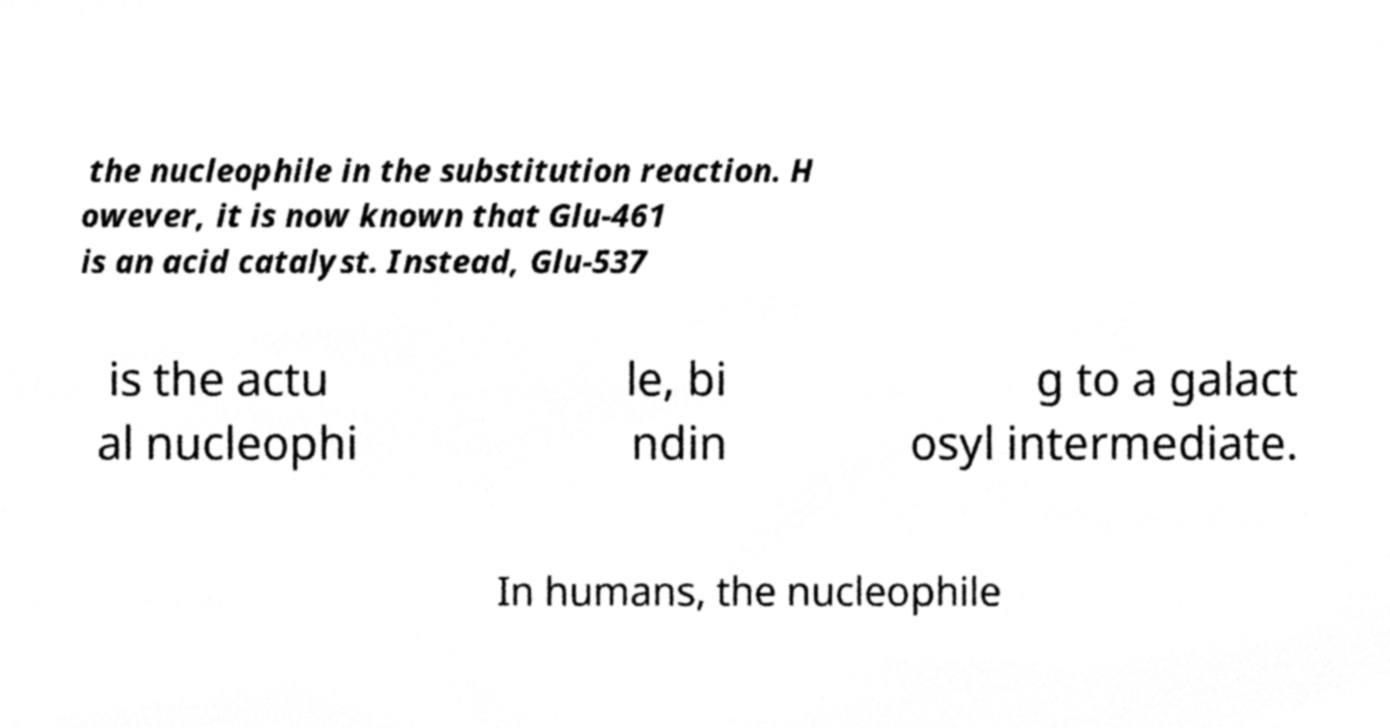Please identify and transcribe the text found in this image. the nucleophile in the substitution reaction. H owever, it is now known that Glu-461 is an acid catalyst. Instead, Glu-537 is the actu al nucleophi le, bi ndin g to a galact osyl intermediate. In humans, the nucleophile 